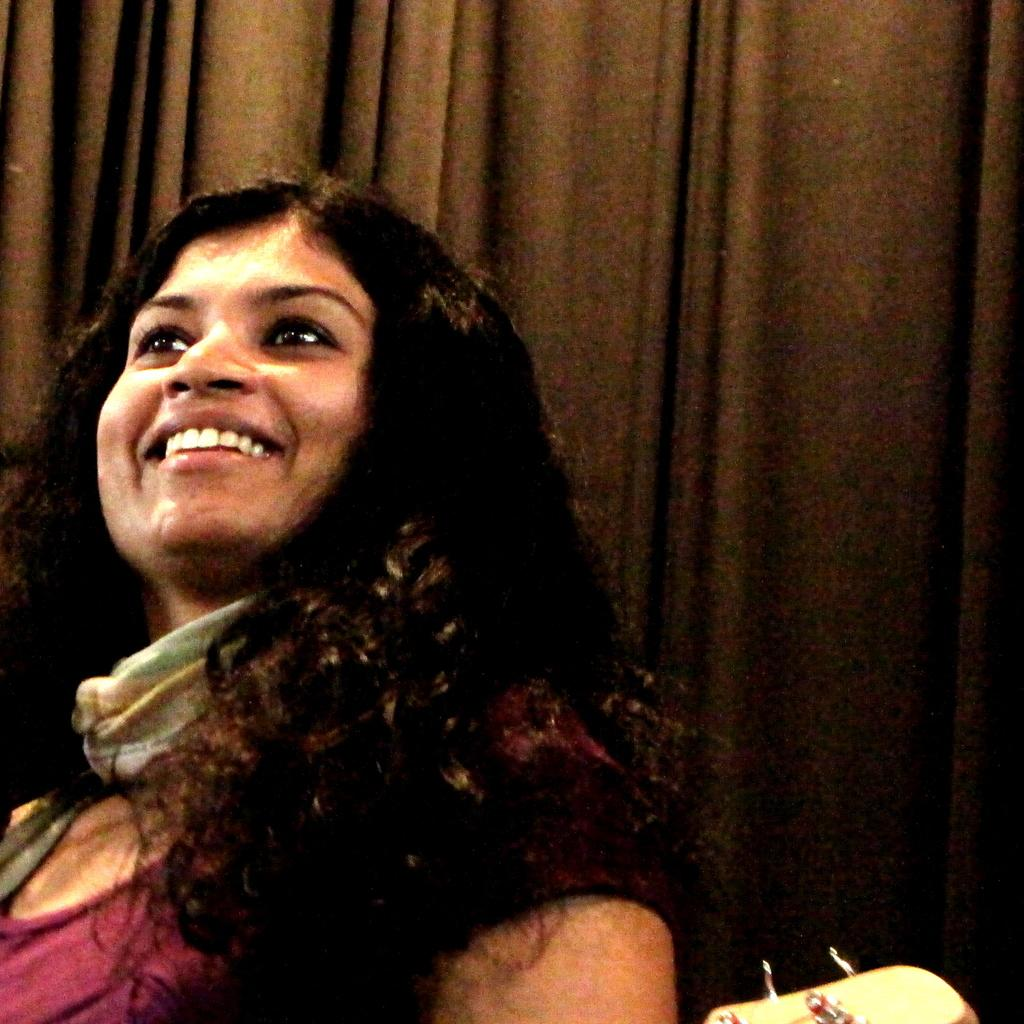What is the primary subject of the image? There is a woman in the image. What is the woman's facial expression? The woman is smiling. What type of object can be seen in the background or surrounding the woman? There is a curtain visible in the image. What type of apparel is the woman wearing to protect her fangs in the image? There is no mention of fangs or any protective apparel in the image. The woman is simply smiling, and there is a curtain visible in the background. 